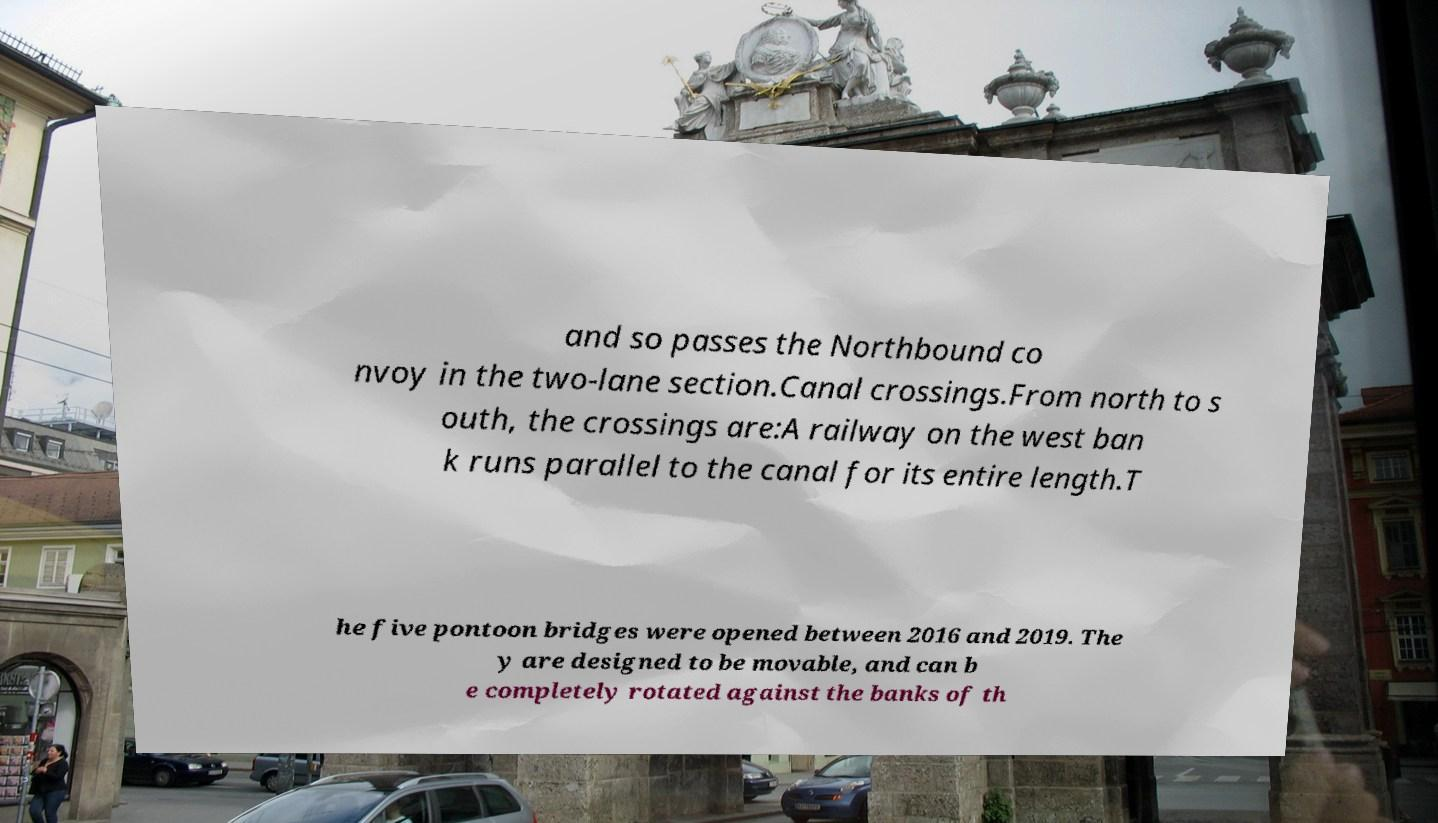What messages or text are displayed in this image? I need them in a readable, typed format. and so passes the Northbound co nvoy in the two-lane section.Canal crossings.From north to s outh, the crossings are:A railway on the west ban k runs parallel to the canal for its entire length.T he five pontoon bridges were opened between 2016 and 2019. The y are designed to be movable, and can b e completely rotated against the banks of th 